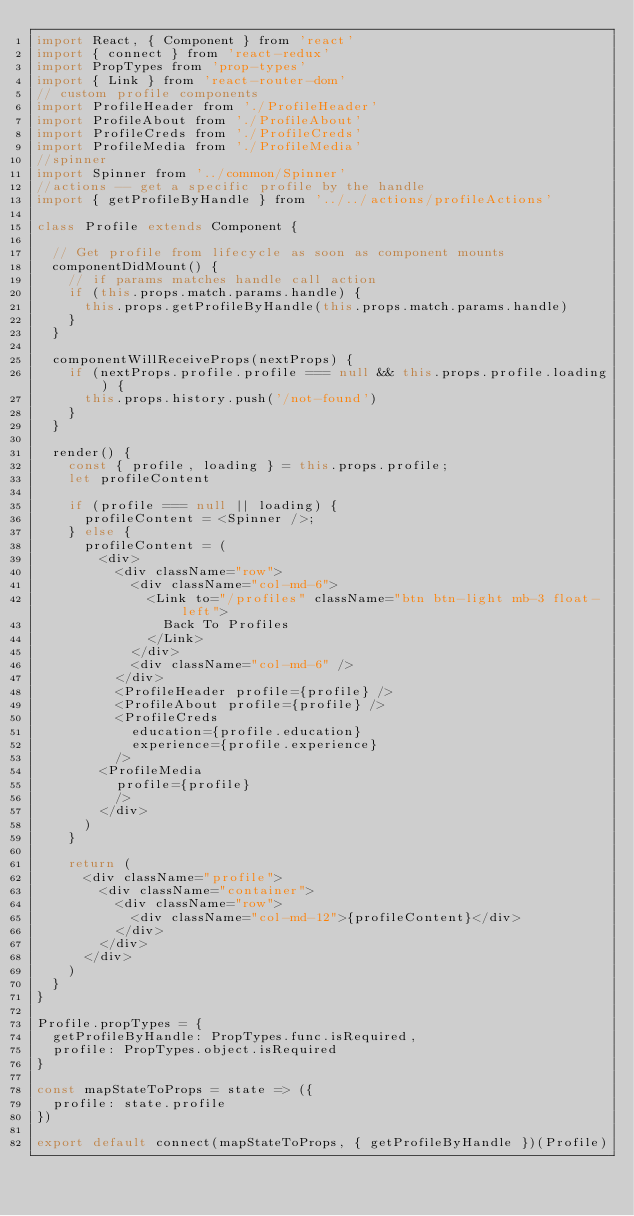Convert code to text. <code><loc_0><loc_0><loc_500><loc_500><_JavaScript_>import React, { Component } from 'react'
import { connect } from 'react-redux'
import PropTypes from 'prop-types'
import { Link } from 'react-router-dom'
// custom profile components
import ProfileHeader from './ProfileHeader'
import ProfileAbout from './ProfileAbout'
import ProfileCreds from './ProfileCreds'
import ProfileMedia from './ProfileMedia'
//spinner
import Spinner from '../common/Spinner'
//actions -- get a specific profile by the handle
import { getProfileByHandle } from '../../actions/profileActions'

class Profile extends Component {

  // Get profile from lifecycle as soon as component mounts
  componentDidMount() {
    // if params matches handle call action
    if (this.props.match.params.handle) {
      this.props.getProfileByHandle(this.props.match.params.handle)
    }
  }

  componentWillReceiveProps(nextProps) {
    if (nextProps.profile.profile === null && this.props.profile.loading) {
      this.props.history.push('/not-found')
    }
  }

  render() {
    const { profile, loading } = this.props.profile;
    let profileContent

    if (profile === null || loading) {
      profileContent = <Spinner />;
    } else {
      profileContent = (
        <div>
          <div className="row">
            <div className="col-md-6">
              <Link to="/profiles" className="btn btn-light mb-3 float-left">
                Back To Profiles
              </Link>
            </div>
            <div className="col-md-6" />
          </div>
          <ProfileHeader profile={profile} />
          <ProfileAbout profile={profile} />
          <ProfileCreds
            education={profile.education}
            experience={profile.experience}
          />
        <ProfileMedia
          profile={profile}
          />
        </div>
      )
    }

    return (
      <div className="profile">
        <div className="container">
          <div className="row">
            <div className="col-md-12">{profileContent}</div>
          </div>
        </div>
      </div>
    )
  }
}

Profile.propTypes = {
  getProfileByHandle: PropTypes.func.isRequired,
  profile: PropTypes.object.isRequired
}

const mapStateToProps = state => ({
  profile: state.profile
})

export default connect(mapStateToProps, { getProfileByHandle })(Profile)
</code> 